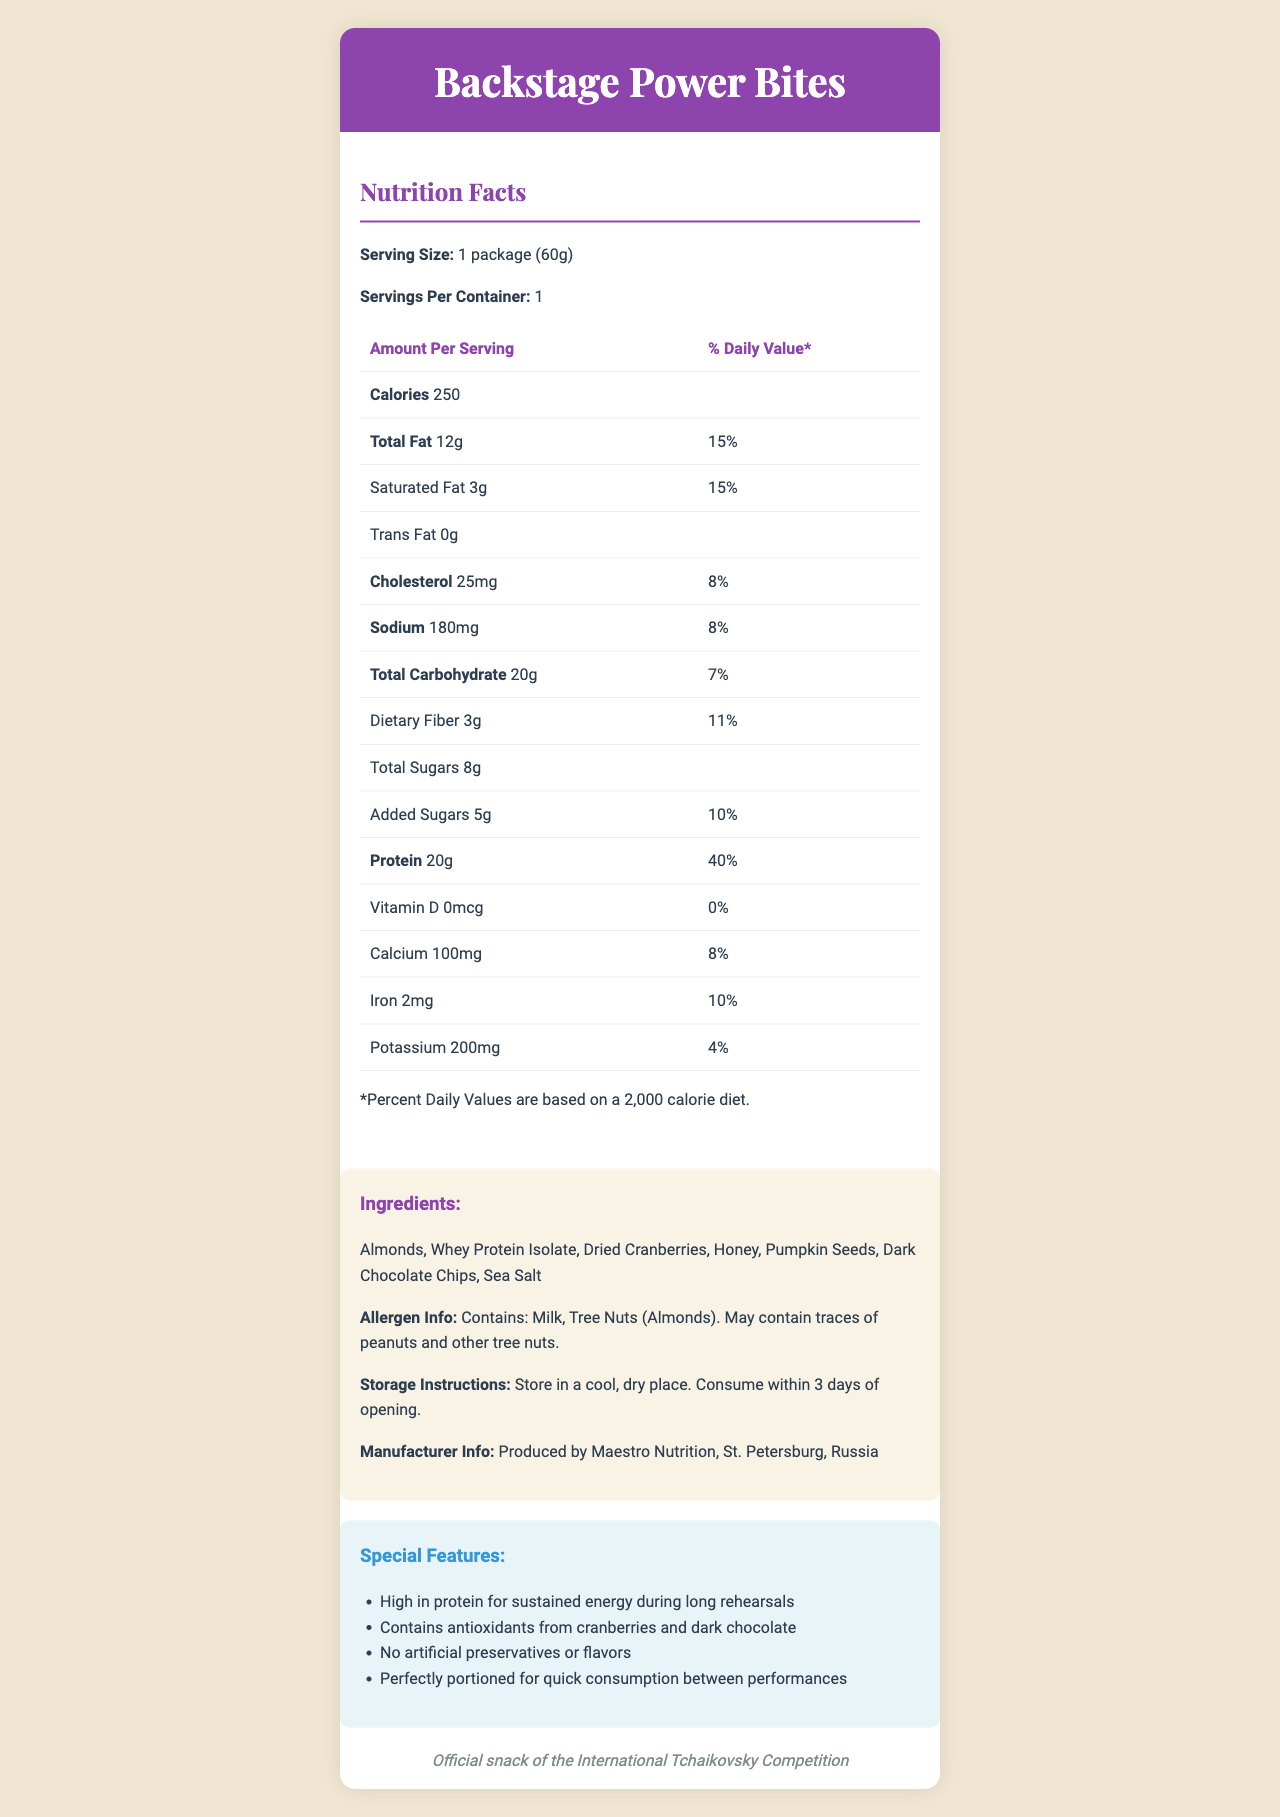what is the serving size of Backstage Power Bites? The serving size is mentioned at the beginning of the Nutrition Facts section as "1 package (60g)".
Answer: 1 package (60g) how many calories are there per serving? The calories per serving are listed as "250" under the Amount Per Serving section.
Answer: 250 what is the total amount of fat per serving? The total amount of fat is specified as "12g" in the Nutrition Facts table.
Answer: 12g which ingredient in Backstage Power Bites could potentially cause allergic reactions in some people due to tree nuts? The ingredients list "Almonds" and also state in the allergen info that it contains tree nuts.
Answer: Almonds what is the protein content per serving and its percent daily value? The protein content per serving is listed as "20g" and its percent daily value is "40%".
Answer: 20g, 40% what percentage of the daily value of saturated fat does one serving of Backstage Power Bites provide? The percent daily value for saturated fat is shown as "15%" in the Nutrition Facts table.
Answer: 15% which special feature of Backstage Power Bites is highlighted for quick consumption?  
A. High in protein  
B. Contains antioxidants  
C. No artificial preservatives  
D. Perfectly portioned for quick consumption The special features list includes "Perfectly portioned for quick consumption between performances".
Answer: D. Perfectly portioned for quick consumption where are Backstage Power Bites produced?  
A. Moscow
B. St. Petersburg
C. Novosibirsk
D. Yekaterinburg The manufacturer info states that the product is produced by Maestro Nutrition in St. Petersburg, Russia.
Answer: B. St. Petersburg does the Nutrition Facts label show any vitamin D content in Backstage Power Bites? The Vitamin D content is listed as "0mcg" and the percent daily value is "0%".
Answer: No summarize the main idea of the document. The document provides comprehensive nutritional information about Backstage Power Bites, highlighting its high protein content and other beneficial attributes. It details ingredients, allergen info, and storage instructions, along with special features tailored for music festival participants. It also mentions the product's branding as the official snack of the International Tchaikovsky Competition.
Answer: Backstage Power Bites is a high-protein snack designed for sustained energy during long rehearsals, with nutritional information detailed in the Nutrition Facts label, including calories, fats, cholesterol, sodium, carbohydrates, protein, vitamins, and minerals. The ingredients include almonds, whey protein isolate, and other nutritious elements. Special features emphasize its suitability for quick consumption and lack of artificial preservatives, along with allergen information and storage instructions. It is produced in St. Petersburg, Russia. does Backstage Power Bites contain any artificial preservatives or flavors? One of the special features states "No artificial preservatives or flavors".
Answer: No how long can Backstage Power Bites be stored after opening before it needs to be consumed? The storage instructions mention to "Consume within 3 days of opening".
Answer: 3 days what is the total carbohydrate content per serving, including dietary fiber and sugars? The total carbohydrate content is outlined as "20g", dietary fiber as "3g", total sugars as "8g", and added sugars as "5g" in the Nutrition Facts table.
Answer: 20g, which includes 3g of dietary fiber and 8g of total sugars (5g added sugars) do Backstage Power Bites provide a significant source of iron? The iron content is listed as "2mg", providing "10%" of the daily value, which is relatively significant.
Answer: Yes how does the amount of potassium in Backstage Power Bites compare to the daily value percentage? The document shows that Backstage Power Bites contain "200mg" of potassium, which corresponds to "4%" of the daily value.
Answer: 200mg, 4% how many servings per container are there? The servings per container are mentioned as "1" in the Nutrition Facts section.
Answer: 1 is dried cranberry listed as the first ingredient? The first ingredient listed is "Almonds", not "Dried Cranberries".
Answer: No what is the total amount of cholesterol per serving? The total amount of cholesterol per serving is listed as "25mg".
Answer: 25mg what is the main purpose of Backstage Power Bites according to the special features? The special features emphasize that it is high in protein for sustained energy during long rehearsals.
Answer: High in protein for sustained energy during long rehearsals where can the fictional document’s nutritional data be found visually? The nutritional data is presented in the Nutrition Facts table within the document.
Answer: In the Nutrition Facts table within the document. 